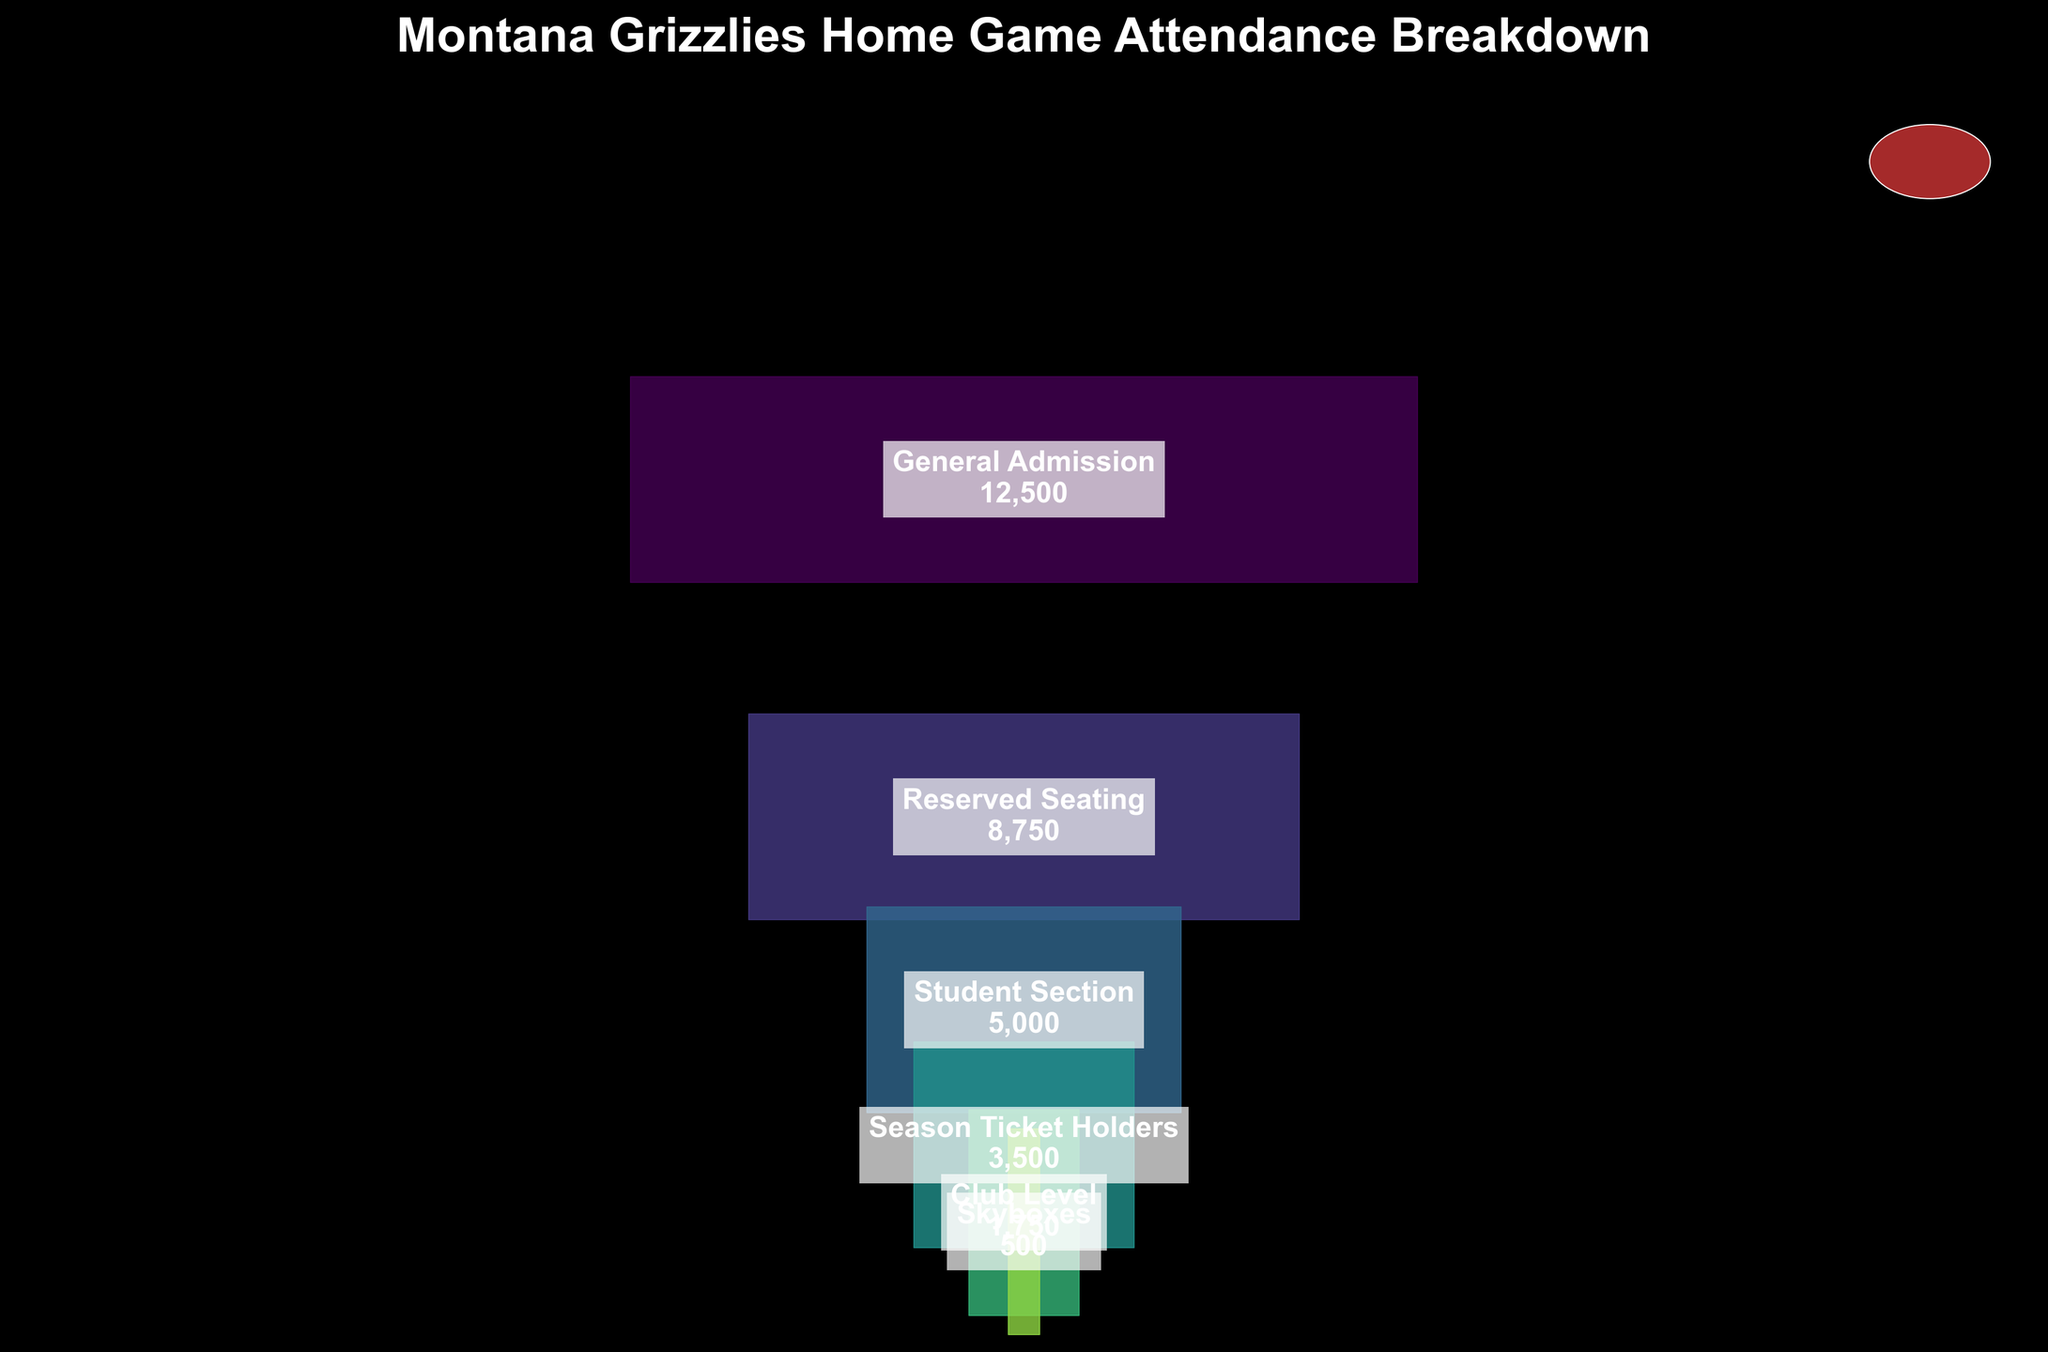Which ticket type sold the most? To find the ticket type that sold the most, look for the largest segment in the funnel chart. The largest segment corresponds to "General Admission" with 12,500 tickets sold.
Answer: General Admission How many tickets were sold for the Club Level? To determine the number of tickets sold for the Club Level, find the segment labeled "Club Level" in the funnel chart. The label indicates 1,750 tickets sold.
Answer: 1,750 What is the total number of tickets sold for student section and reserved seating combined? Add the number of tickets sold for the "Student Section" and "Reserved Seating". From the chart, these values are 5,000 and 8,750, respectively. Adding them together, 5,000 + 8,750 = 13,750.
Answer: 13,750 Which ticket type sold the least? Look for the smallest segment in the funnel chart. The smallest segment corresponds to "Skyboxes" with 500 tickets sold.
Answer: Skyboxes How does the number of tickets sold to season ticket holders compare to those sold for reserved seating? Compare the segment lengths for "Season Ticket Holders" and "Reserved Seating". "Reserved Seating" sold 8,750 tickets, while "Season Ticket Holders" sold 3,500. Reserved seating sold more tickets.
Answer: Reserved Seating sold more What percentage of the total tickets sold does the General Admission represent? To find this percentage, divide the number of General Admission tickets by the total number of tickets sold and multiply by 100. General Admission: 12,500. Total: 12,500 + 8,750 + 5,000 + 3,500 + 1,750 + 500 = 32,000. (12,500 / 32,000) * 100 ≈ 39.06%.
Answer: 39.06% How many more tickets were sold in General Admission compared to the Student Section? Subtract the tickets sold for the Student Section from those for General Admission. General Admission: 12,500. Student Section: 5,000. 12,500 - 5,000 = 7,500.
Answer: 7,500 Is the number of tickets sold for Skyboxes more or less than Club Level? Compare the segments for "Skyboxes" and "Club Level". Skyboxes sold 500 tickets, and Club Level sold 1,750 tickets. Skyboxes sold fewer tickets than Club Level.
Answer: Less What are the middle two ticket categories in terms of tickets sold? Arrange categories by the number of tickets sold: 500 (Skyboxes), 1,750 (Club Level), 3,500 (Season Ticket Holders), 5,000 (Student Section), 8,750 (Reserved Seating), 12,500 (General Admission). The middle two categories are "Season Ticket Holders" and "Student Section".
Answer: Season Ticket Holders and Student Section What is the difference in tickets sold between Reserved Seating and Club Level? Subtract the tickets sold in Club Level from Reserved Seating. Reserved Seating: 8,750. Club Level: 1,750. 8,750 - 1,750 = 7,000.
Answer: 7,000 